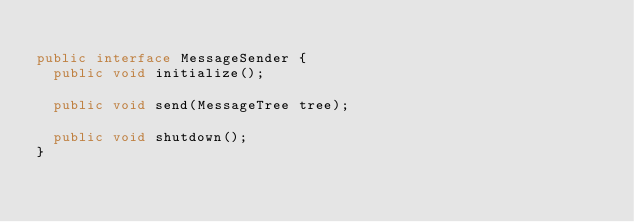Convert code to text. <code><loc_0><loc_0><loc_500><loc_500><_Java_>
public interface MessageSender {
	public void initialize();

	public void send(MessageTree tree);

	public void shutdown();
}
</code> 